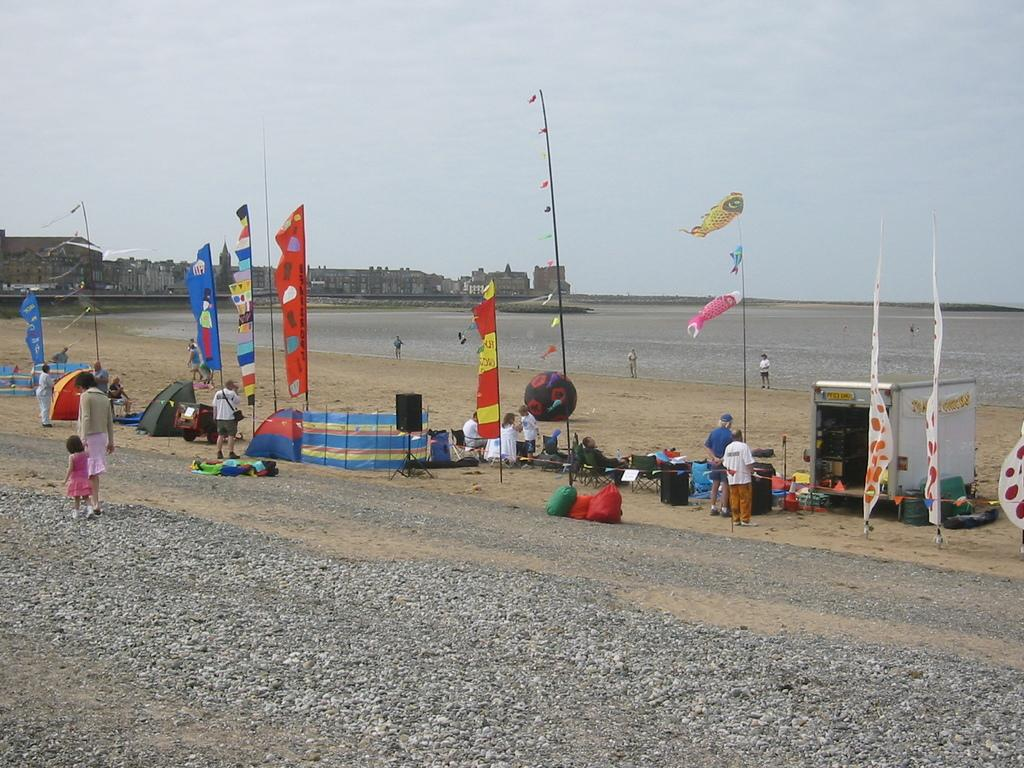What type of location is depicted in the image? There is a beach in the image. Are there any people present in the image? Yes, there are people in the image. What can be seen flying in the image? There are flags visible in the image. What type of temporary shelter is present in the image? There are tents in the image. What type of structures can be seen in the background of the image? There are buildings in the image. What emotion is the beach feeling in the image? The beach is not capable of feeling emotions, as it is an inanimate object. 